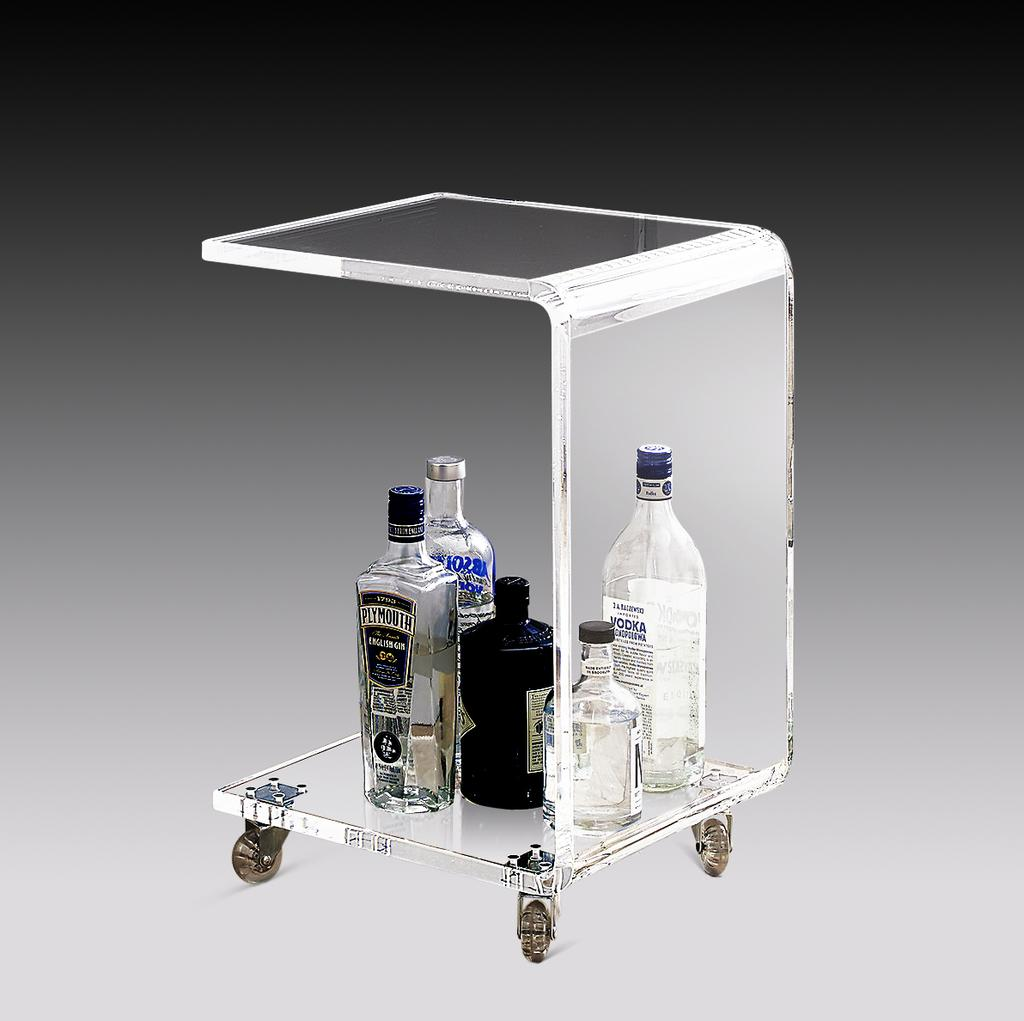What objects can be seen in the image? There are bottles in the image. Can you see any goldfish swimming in the bottles in the image? There are no goldfish present in the image; it only features bottles. Is there a scarf wrapped around any of the bottles in the image? There is no scarf present in the image; it only features bottles. 